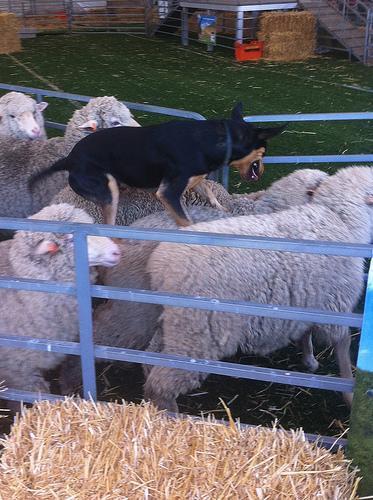How many sheep are visible in the picture?
Give a very brief answer. 6. How many dogs are in the picture?
Give a very brief answer. 1. 